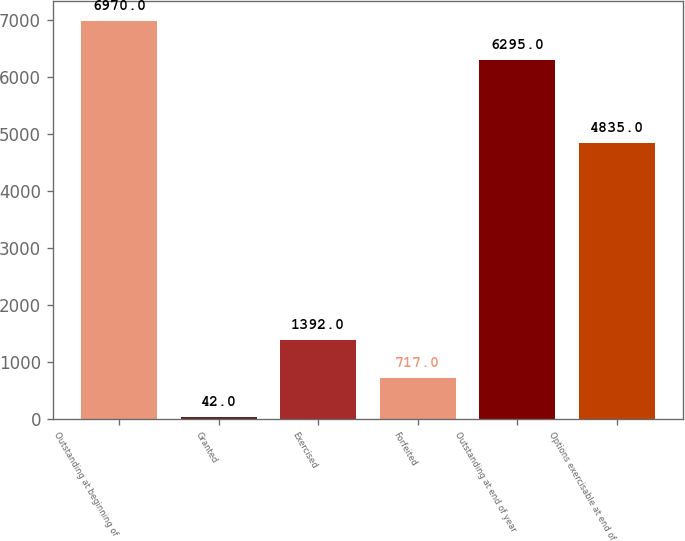<chart> <loc_0><loc_0><loc_500><loc_500><bar_chart><fcel>Outstanding at beginning of<fcel>Granted<fcel>Exercised<fcel>Forfeited<fcel>Outstanding at end of year<fcel>Options exercisable at end of<nl><fcel>6970<fcel>42<fcel>1392<fcel>717<fcel>6295<fcel>4835<nl></chart> 